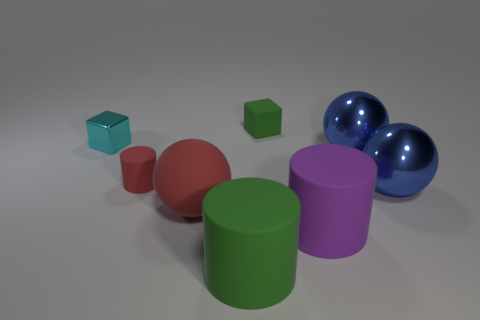Subtract all big metal spheres. How many spheres are left? 1 Subtract all yellow cylinders. How many blue balls are left? 2 Add 2 big blue balls. How many objects exist? 10 Subtract 1 balls. How many balls are left? 2 Subtract all blue cylinders. Subtract all yellow blocks. How many cylinders are left? 3 Add 2 tiny rubber cubes. How many tiny rubber cubes are left? 3 Add 5 gray metallic balls. How many gray metallic balls exist? 5 Subtract 0 cyan cylinders. How many objects are left? 8 Subtract all blocks. How many objects are left? 6 Subtract all metallic balls. Subtract all matte things. How many objects are left? 1 